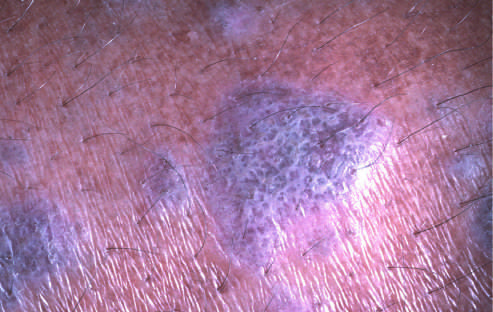re these hormones referred to as wickham striae?
Answer the question using a single word or phrase. No 